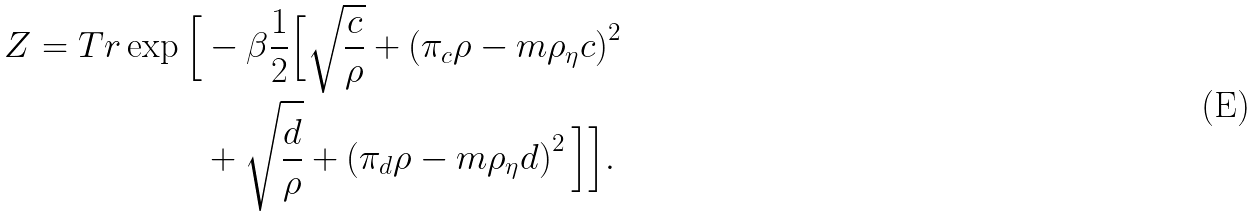<formula> <loc_0><loc_0><loc_500><loc_500>Z = T r \exp \Big { [ } & - \beta \frac { 1 } { 2 } \Big { [ } \sqrt { \frac { c } { \rho } } + \left ( \pi _ { c } \rho - m \rho _ { \eta } c \right ) ^ { 2 } \\ & + \sqrt { \frac { d } { \rho } } + \left ( \pi _ { d } \rho - m \rho _ { \eta } d \right ) ^ { 2 } \Big { ] } \Big { ] } .</formula> 